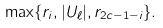<formula> <loc_0><loc_0><loc_500><loc_500>\max \{ r _ { i } , | U _ { \ell } | , r _ { 2 c - 1 - i } \} .</formula> 